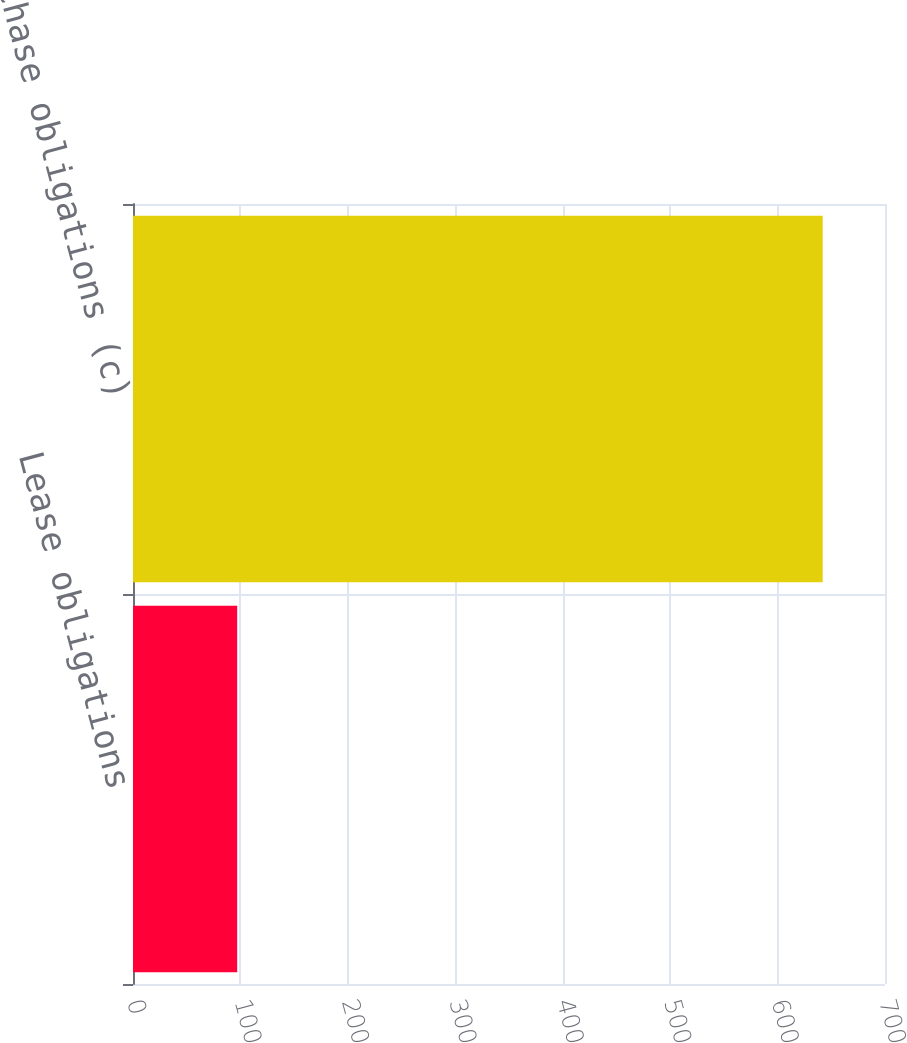<chart> <loc_0><loc_0><loc_500><loc_500><bar_chart><fcel>Lease obligations<fcel>Purchase obligations (c)<nl><fcel>97<fcel>642<nl></chart> 